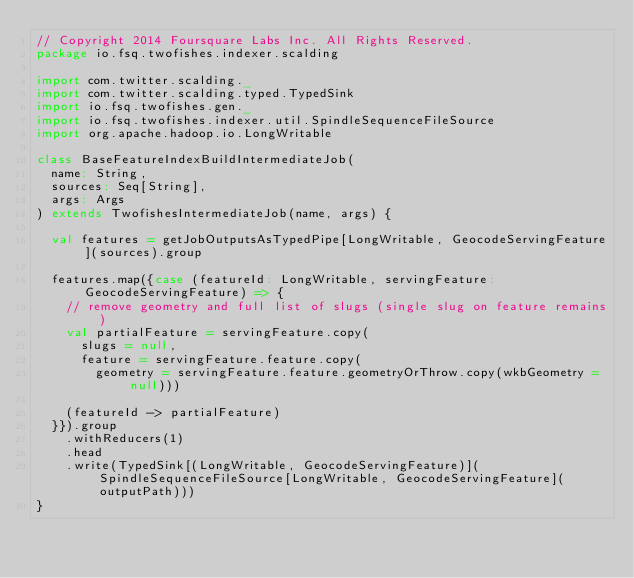<code> <loc_0><loc_0><loc_500><loc_500><_Scala_>// Copyright 2014 Foursquare Labs Inc. All Rights Reserved.
package io.fsq.twofishes.indexer.scalding

import com.twitter.scalding._
import com.twitter.scalding.typed.TypedSink
import io.fsq.twofishes.gen._
import io.fsq.twofishes.indexer.util.SpindleSequenceFileSource
import org.apache.hadoop.io.LongWritable

class BaseFeatureIndexBuildIntermediateJob(
  name: String,
  sources: Seq[String],
  args: Args
) extends TwofishesIntermediateJob(name, args) {

  val features = getJobOutputsAsTypedPipe[LongWritable, GeocodeServingFeature](sources).group

  features.map({case (featureId: LongWritable, servingFeature: GeocodeServingFeature) => {
    // remove geometry and full list of slugs (single slug on feature remains)
    val partialFeature = servingFeature.copy(
      slugs = null,
      feature = servingFeature.feature.copy(
        geometry = servingFeature.feature.geometryOrThrow.copy(wkbGeometry = null)))

    (featureId -> partialFeature)
  }}).group
    .withReducers(1)
    .head
    .write(TypedSink[(LongWritable, GeocodeServingFeature)](SpindleSequenceFileSource[LongWritable, GeocodeServingFeature](outputPath)))
}
</code> 